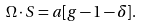<formula> <loc_0><loc_0><loc_500><loc_500>\Omega \cdot S = a [ g - 1 - \delta ] .</formula> 